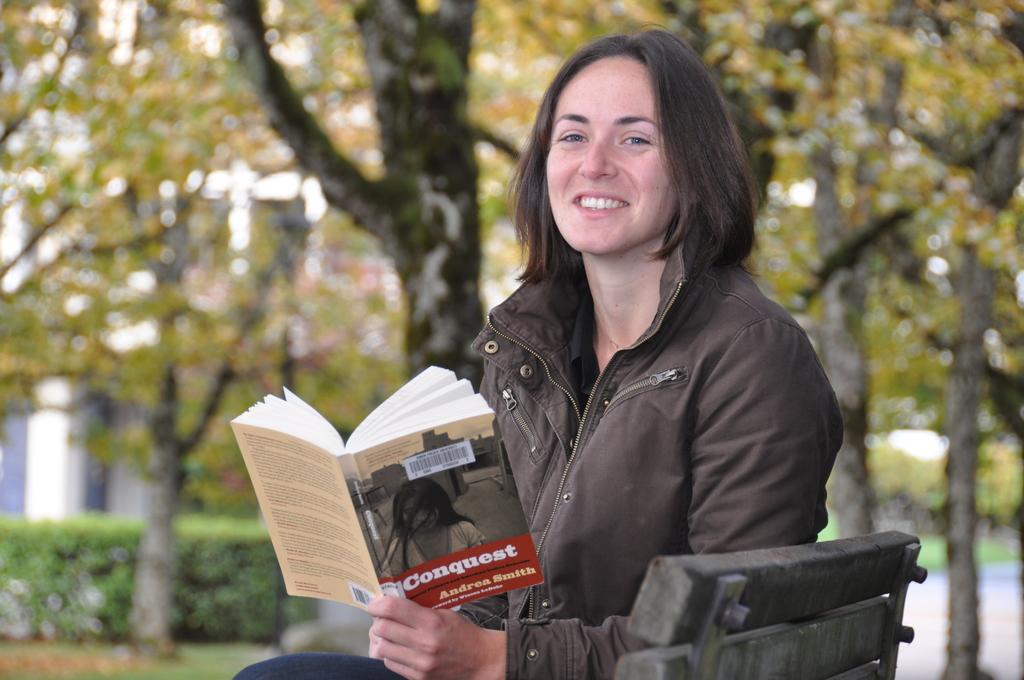Who is the author of the book?
Make the answer very short. Andrea smith. 